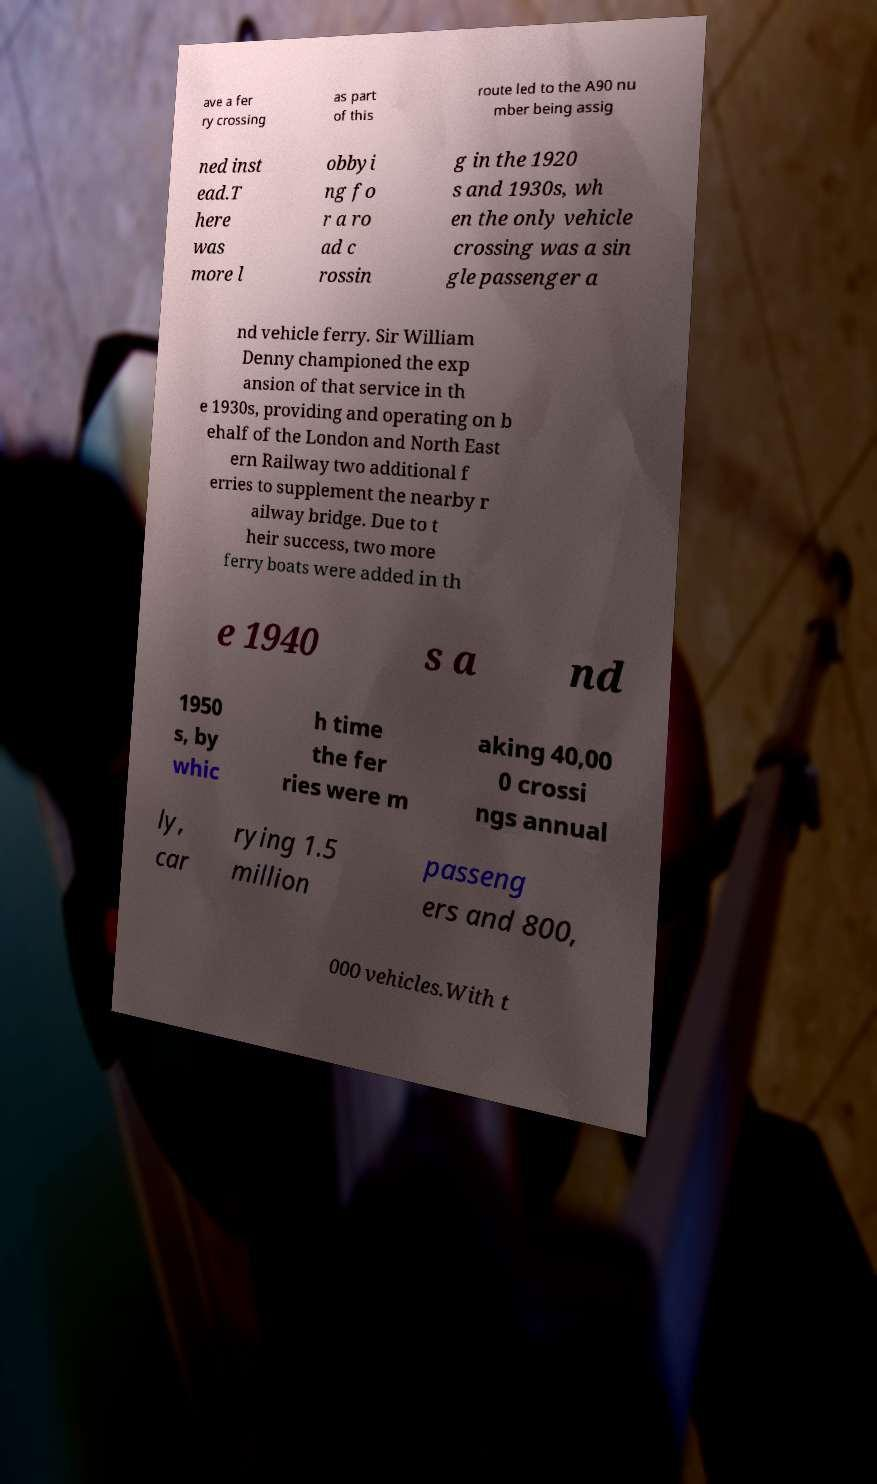I need the written content from this picture converted into text. Can you do that? ave a fer ry crossing as part of this route led to the A90 nu mber being assig ned inst ead.T here was more l obbyi ng fo r a ro ad c rossin g in the 1920 s and 1930s, wh en the only vehicle crossing was a sin gle passenger a nd vehicle ferry. Sir William Denny championed the exp ansion of that service in th e 1930s, providing and operating on b ehalf of the London and North East ern Railway two additional f erries to supplement the nearby r ailway bridge. Due to t heir success, two more ferry boats were added in th e 1940 s a nd 1950 s, by whic h time the fer ries were m aking 40,00 0 crossi ngs annual ly, car rying 1.5 million passeng ers and 800, 000 vehicles.With t 